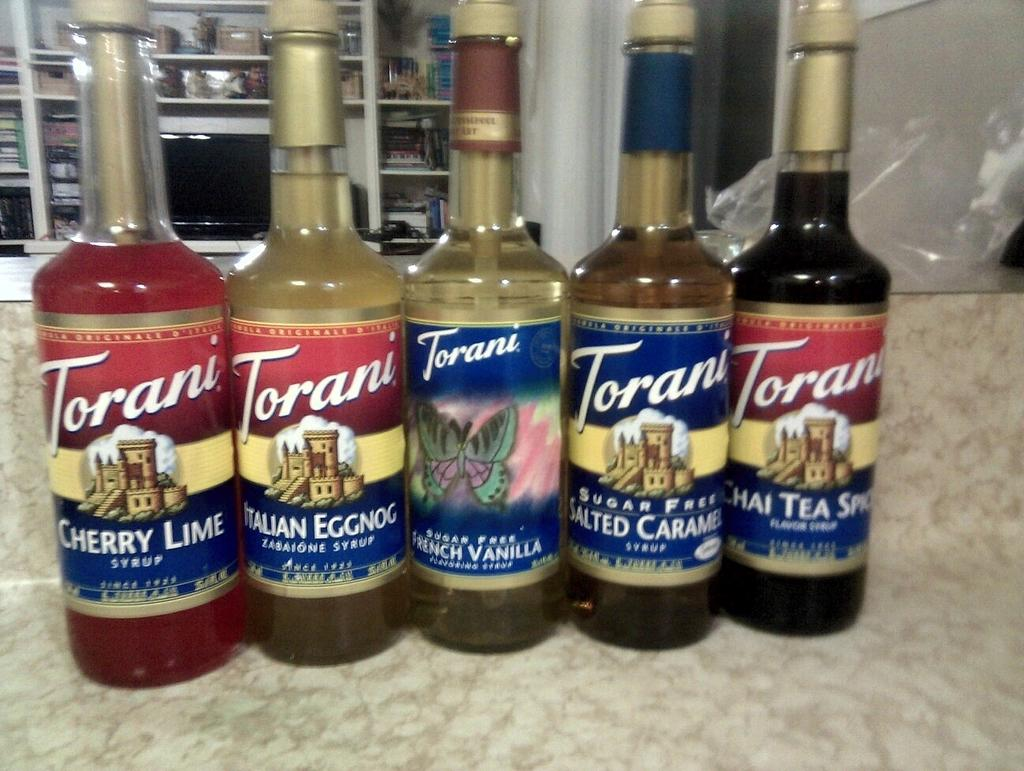<image>
Provide a brief description of the given image. Several bottles of Torani sit in a row on counter 